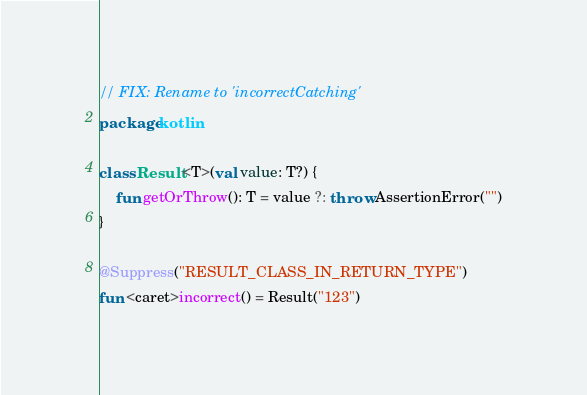Convert code to text. <code><loc_0><loc_0><loc_500><loc_500><_Kotlin_>// FIX: Rename to 'incorrectCatching'
package kotlin

class Result<T>(val value: T?) {
    fun getOrThrow(): T = value ?: throw AssertionError("")
}

@Suppress("RESULT_CLASS_IN_RETURN_TYPE")
fun <caret>incorrect() = Result("123")
</code> 